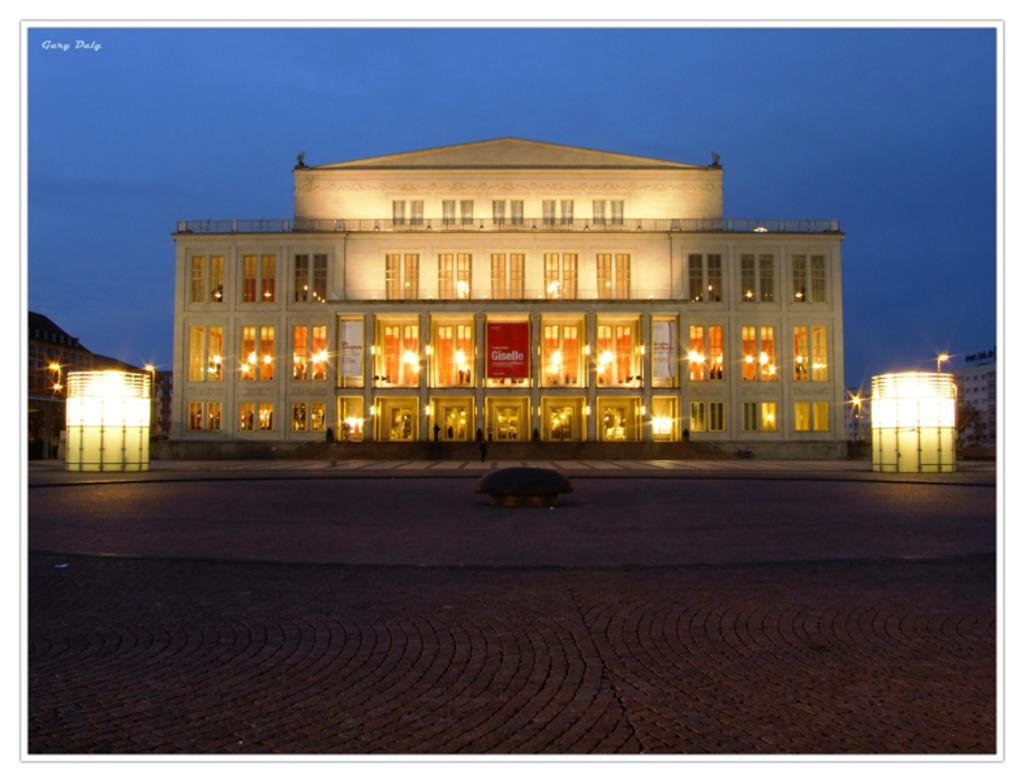What type of structure is visible in the image? There is a building in the image. What feature can be seen on the building? The building has windows. What is the path made of in the image? There is a footpath in the image. What can be used to provide illumination in the image? There are lights in the image. What is the purpose of the board in the image? There is a board in the image, but its purpose is not specified. What is the watermark in the image? There is a watermark in the image, but its purpose or content is not specified. What type of natural feature is visible in the image? There is a mountain in the image. What is the color of the sky in the image? The sky is blue in the image. What type of smell can be detected coming from the mountain in the image? There is no information about smells in the image, and the mountain is not described as having any specific scent. Can you tell me the name of the parent of the person who took the image? There is no information about the person who took the image or their parents in the image. 